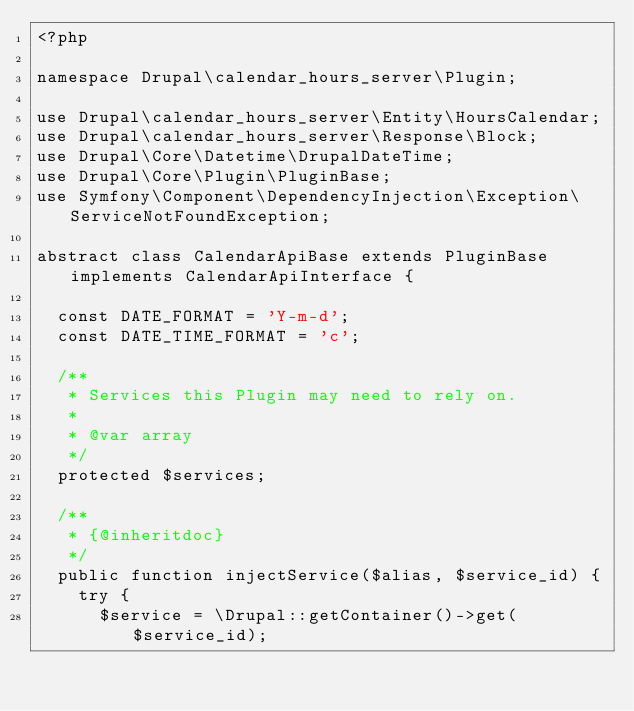Convert code to text. <code><loc_0><loc_0><loc_500><loc_500><_PHP_><?php

namespace Drupal\calendar_hours_server\Plugin;

use Drupal\calendar_hours_server\Entity\HoursCalendar;
use Drupal\calendar_hours_server\Response\Block;
use Drupal\Core\Datetime\DrupalDateTime;
use Drupal\Core\Plugin\PluginBase;
use Symfony\Component\DependencyInjection\Exception\ServiceNotFoundException;

abstract class CalendarApiBase extends PluginBase implements CalendarApiInterface {

  const DATE_FORMAT = 'Y-m-d';
  const DATE_TIME_FORMAT = 'c';

  /**
   * Services this Plugin may need to rely on.
   *
   * @var array
   */
  protected $services;

  /**
   * {@inheritdoc}
   */
  public function injectService($alias, $service_id) {
    try {
      $service = \Drupal::getContainer()->get($service_id);</code> 